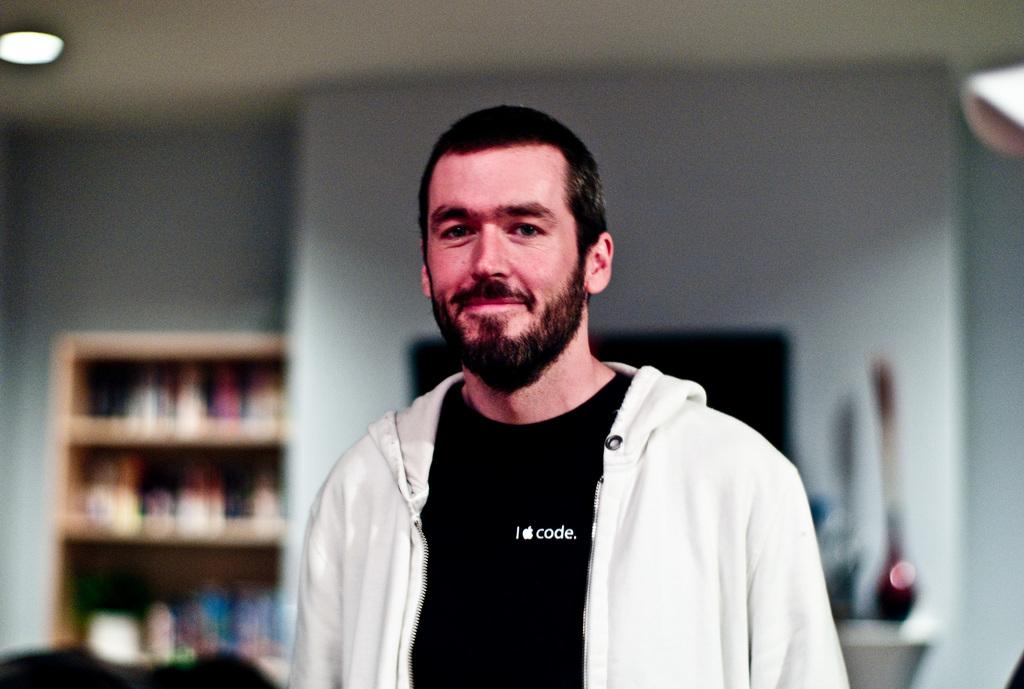What does he apple?
Make the answer very short. Code. 